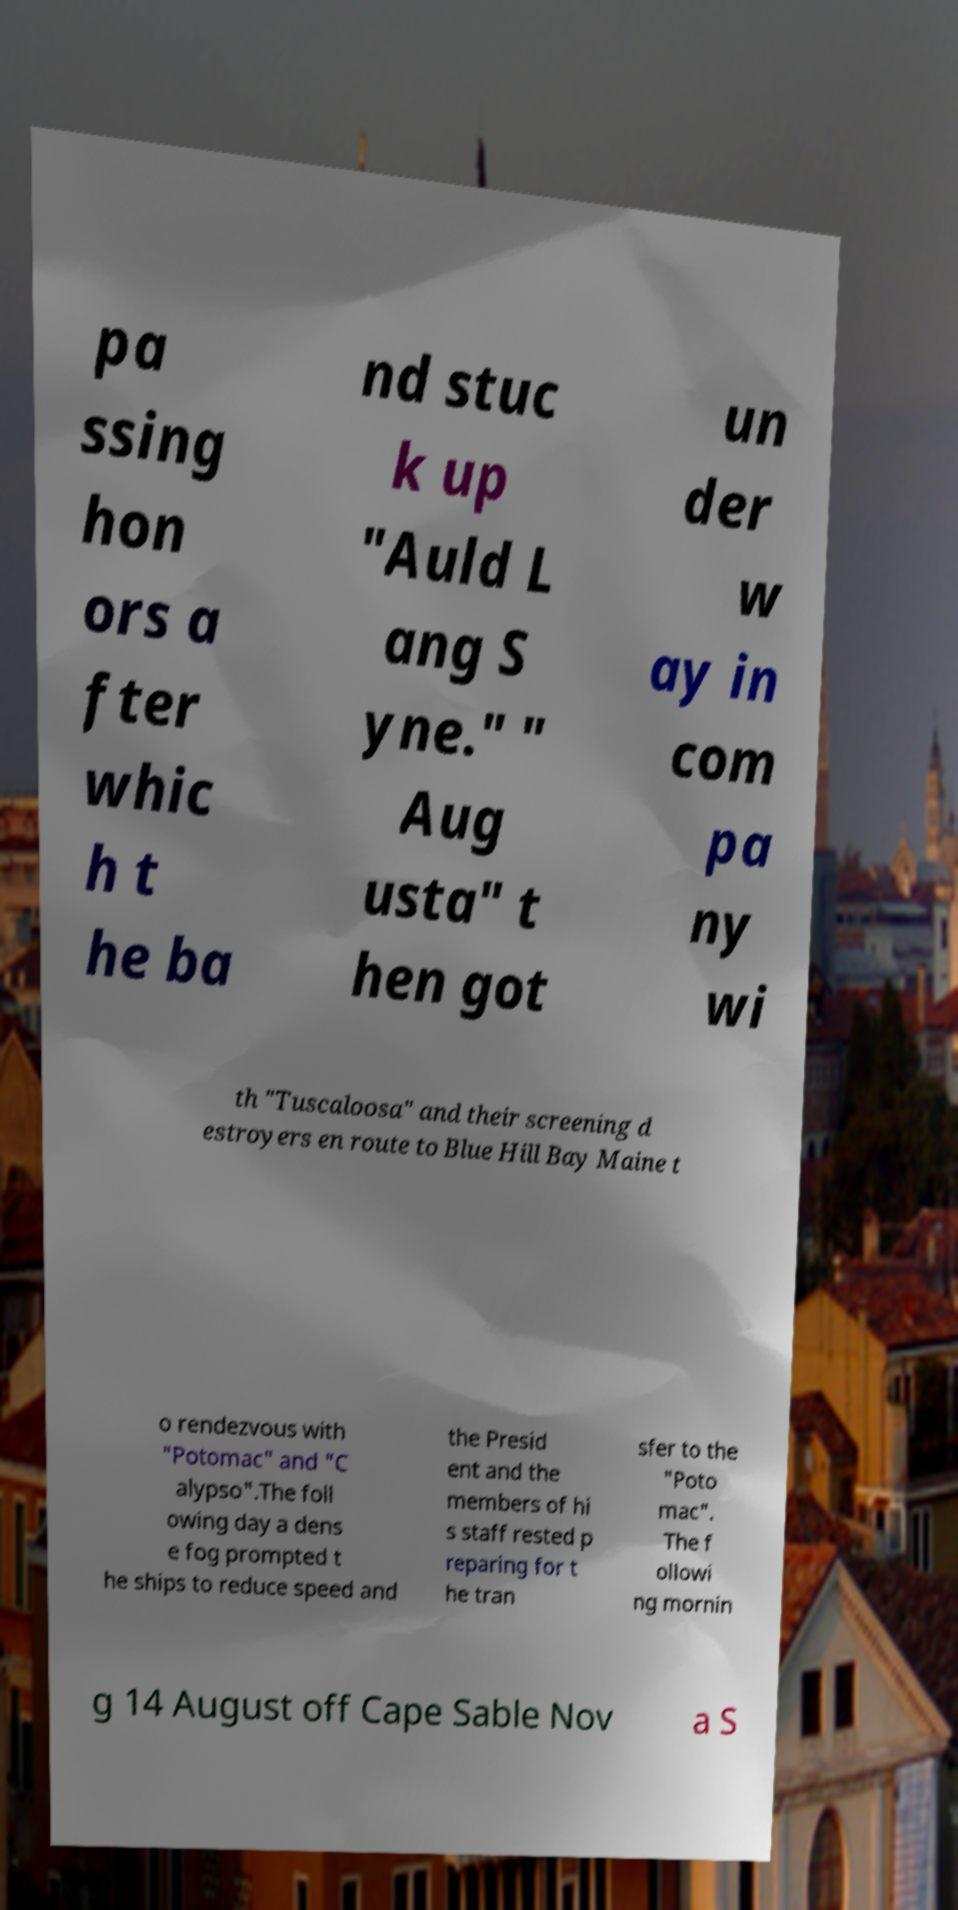I need the written content from this picture converted into text. Can you do that? pa ssing hon ors a fter whic h t he ba nd stuc k up "Auld L ang S yne." " Aug usta" t hen got un der w ay in com pa ny wi th "Tuscaloosa" and their screening d estroyers en route to Blue Hill Bay Maine t o rendezvous with "Potomac" and "C alypso".The foll owing day a dens e fog prompted t he ships to reduce speed and the Presid ent and the members of hi s staff rested p reparing for t he tran sfer to the "Poto mac". The f ollowi ng mornin g 14 August off Cape Sable Nov a S 